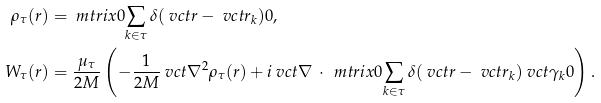<formula> <loc_0><loc_0><loc_500><loc_500>\rho _ { \tau } ( r ) & = \ m t r i x { 0 } { \sum _ { k \in \tau } \delta ( \ v c t { r } - \ v c t { r } _ { k } ) } { 0 } , \\ W _ { \tau } ( r ) & = \frac { \mu _ { \tau } } { 2 M } \left ( - \frac { 1 } { 2 M } \ v c t { \nabla } ^ { 2 } \rho _ { \tau } ( r ) + i \ v c t { \nabla } \, \cdot \, \ m t r i x { 0 } { \sum _ { k \in \tau } \delta ( \ v c t { r } - \ v c t { r } _ { k } ) \ v c t { \gamma } _ { k } } { 0 } \right ) .</formula> 